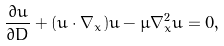Convert formula to latex. <formula><loc_0><loc_0><loc_500><loc_500>\frac { \partial u } { \partial D } + ( u \cdot \nabla _ { x } ) u - \mu \nabla _ { x } ^ { 2 } u = 0 ,</formula> 